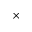Convert formula to latex. <formula><loc_0><loc_0><loc_500><loc_500>\times</formula> 